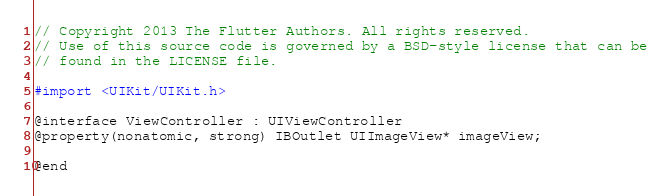Convert code to text. <code><loc_0><loc_0><loc_500><loc_500><_C_>// Copyright 2013 The Flutter Authors. All rights reserved.
// Use of this source code is governed by a BSD-style license that can be
// found in the LICENSE file.

#import <UIKit/UIKit.h>

@interface ViewController : UIViewController
@property(nonatomic, strong) IBOutlet UIImageView* imageView;

@end
</code> 